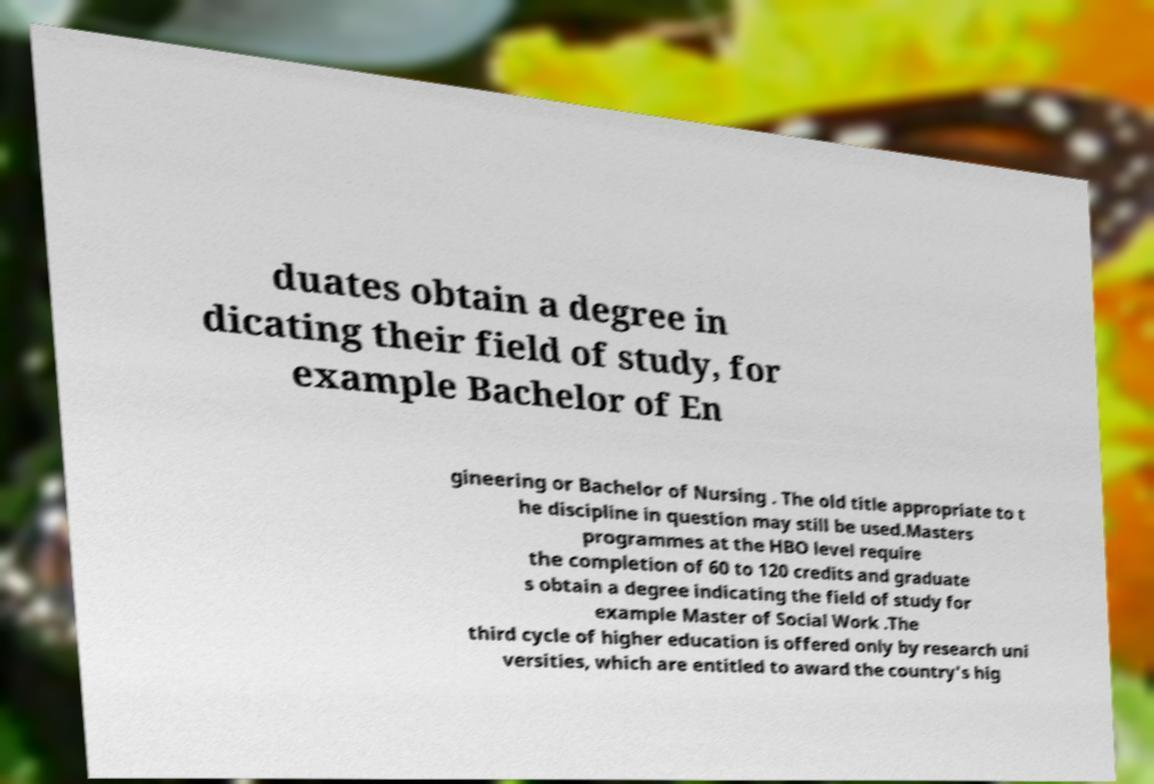Can you accurately transcribe the text from the provided image for me? duates obtain a degree in dicating their field of study, for example Bachelor of En gineering or Bachelor of Nursing . The old title appropriate to t he discipline in question may still be used.Masters programmes at the HBO level require the completion of 60 to 120 credits and graduate s obtain a degree indicating the field of study for example Master of Social Work .The third cycle of higher education is offered only by research uni versities, which are entitled to award the country's hig 